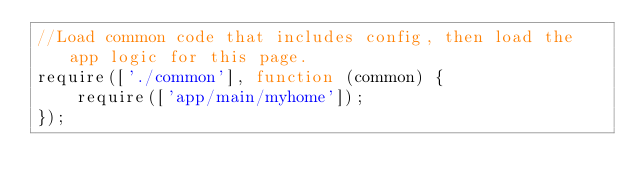<code> <loc_0><loc_0><loc_500><loc_500><_JavaScript_>//Load common code that includes config, then load the app logic for this page.
require(['./common'], function (common) {
    require(['app/main/myhome']);
});
</code> 